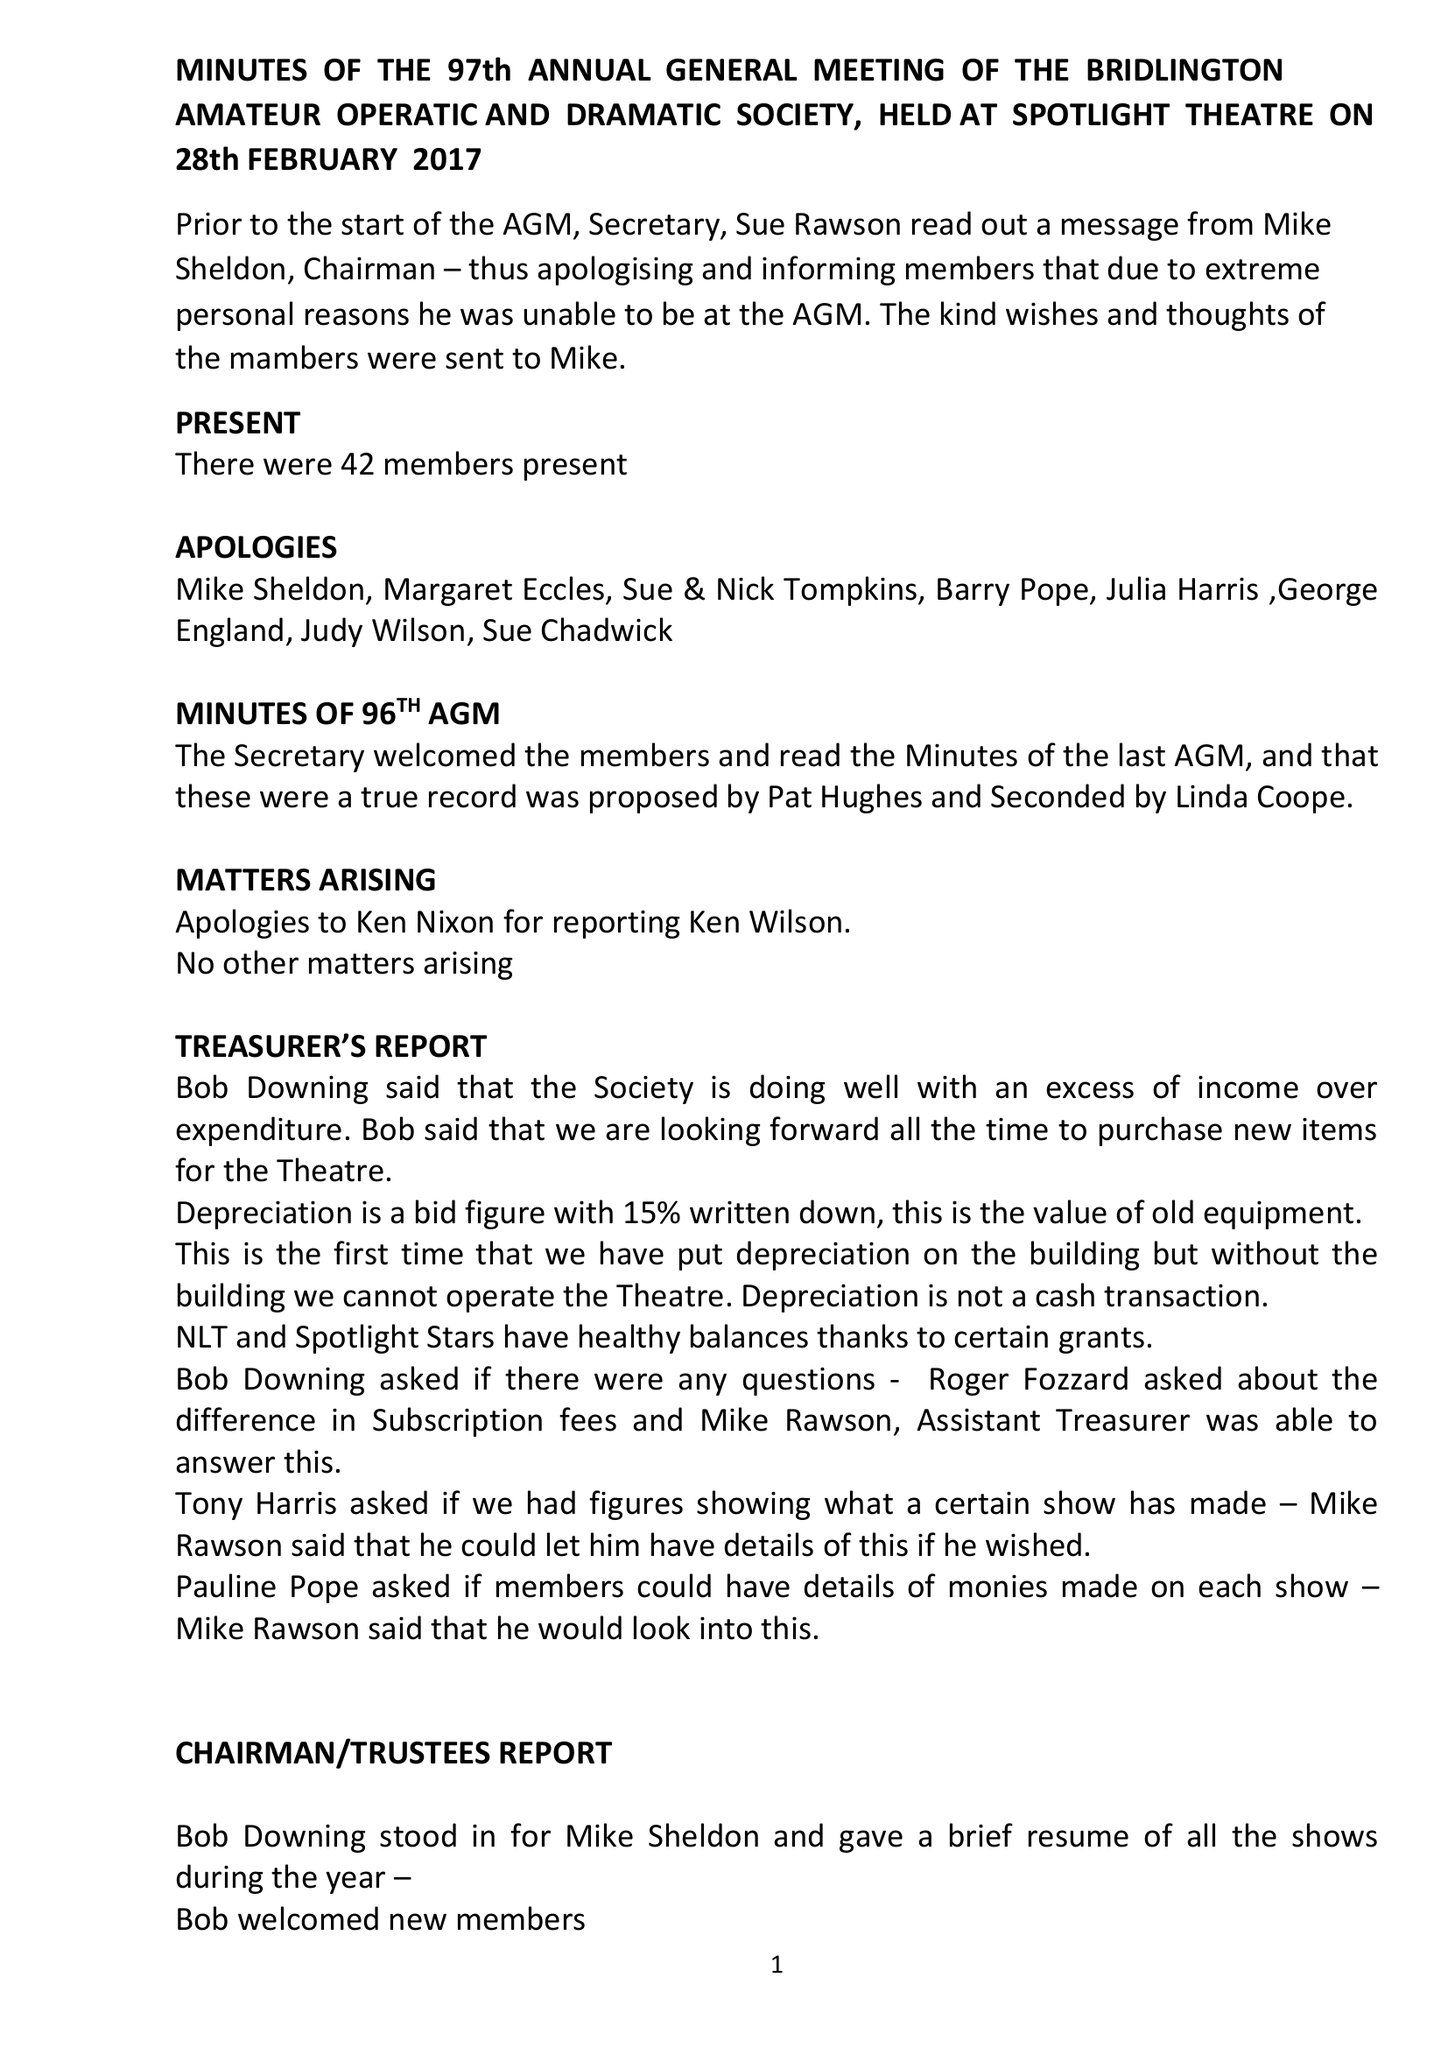What is the value for the charity_number?
Answer the question using a single word or phrase. 231760 